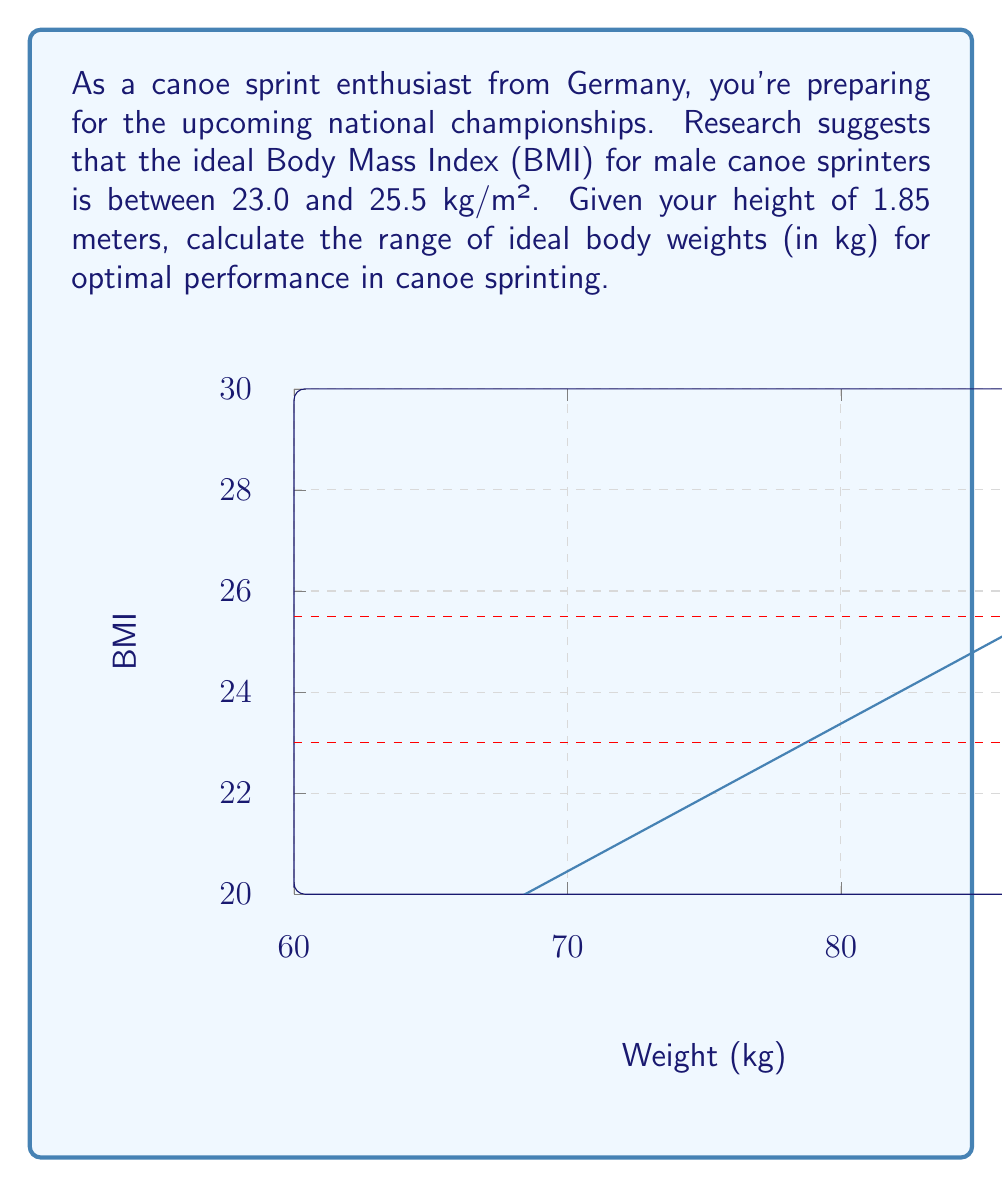Provide a solution to this math problem. To solve this problem, we'll use the BMI formula and work backwards to find the weight range:

1) The BMI formula is:
   $$ BMI = \frac{weight (kg)}{height (m)^2} $$

2) We're given the height (h) of 1.85 m and the ideal BMI range of 23.0 to 25.5 kg/m².

3) Let's solve for weight (w) by rearranging the formula:
   $$ w = BMI \times h^2 $$

4) For the lower bound (BMI = 23.0):
   $$ w_{lower} = 23.0 \times (1.85)^2 = 23.0 \times 3.4225 = 78.7175 \text{ kg} $$

5) For the upper bound (BMI = 25.5):
   $$ w_{upper} = 25.5 \times (1.85)^2 = 25.5 \times 3.4225 = 87.27375 \text{ kg} $$

6) Rounding to one decimal place for practicality:
   Lower bound: 78.7 kg
   Upper bound: 87.3 kg

Therefore, the ideal weight range for a 1.85 m tall canoe sprinter is approximately 78.7 kg to 87.3 kg.
Answer: 78.7 kg to 87.3 kg 